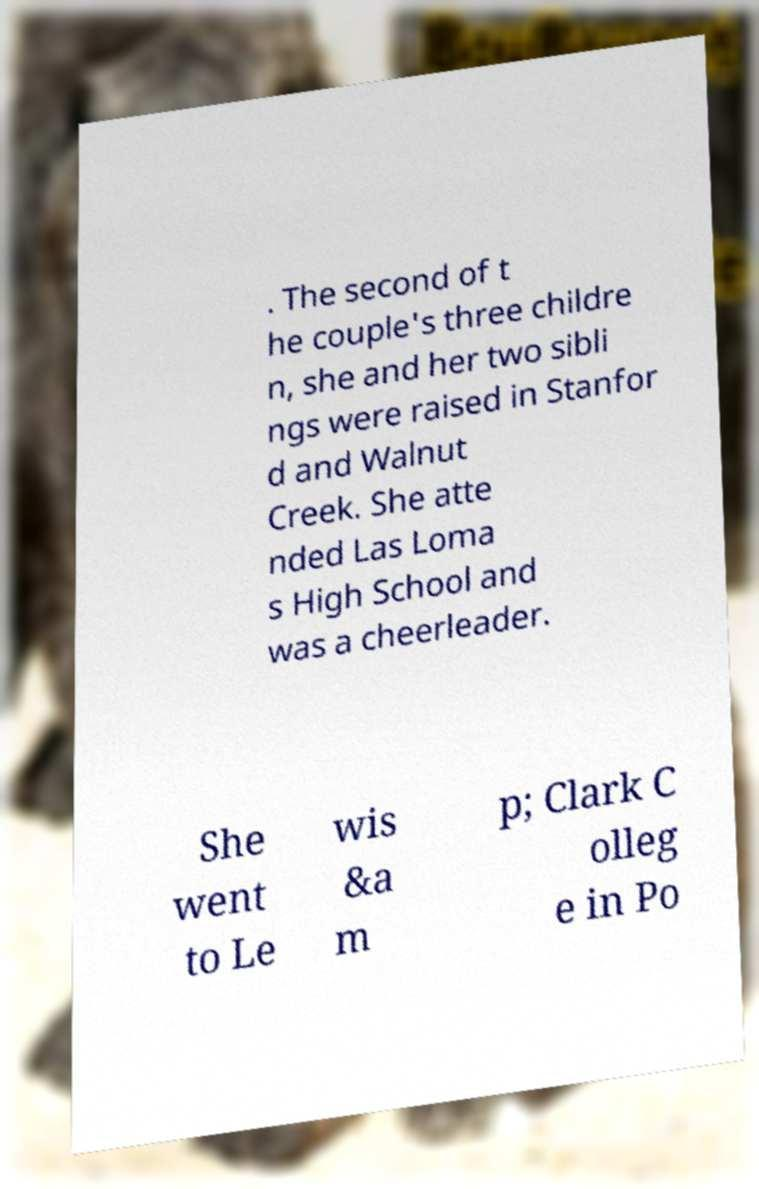There's text embedded in this image that I need extracted. Can you transcribe it verbatim? . The second of t he couple's three childre n, she and her two sibli ngs were raised in Stanfor d and Walnut Creek. She atte nded Las Loma s High School and was a cheerleader. She went to Le wis &a m p; Clark C olleg e in Po 